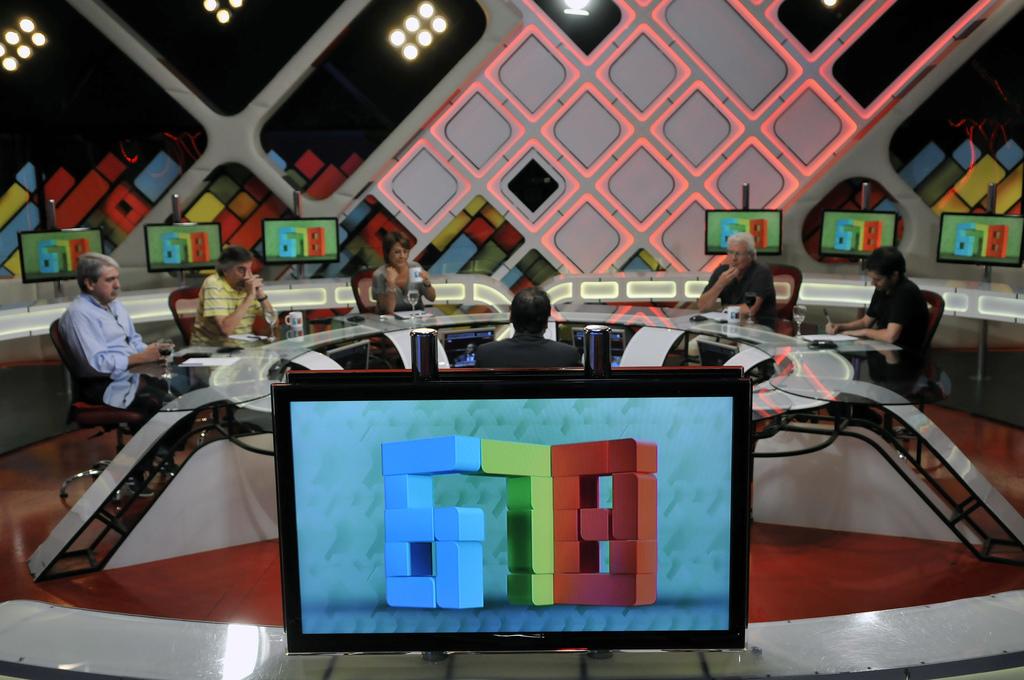What numbers are on the screen?
Keep it short and to the point. 678. Which color is displayed in blue?
Give a very brief answer. Answering does not require reading text in the image. 